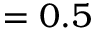<formula> <loc_0><loc_0><loc_500><loc_500>= 0 . 5</formula> 